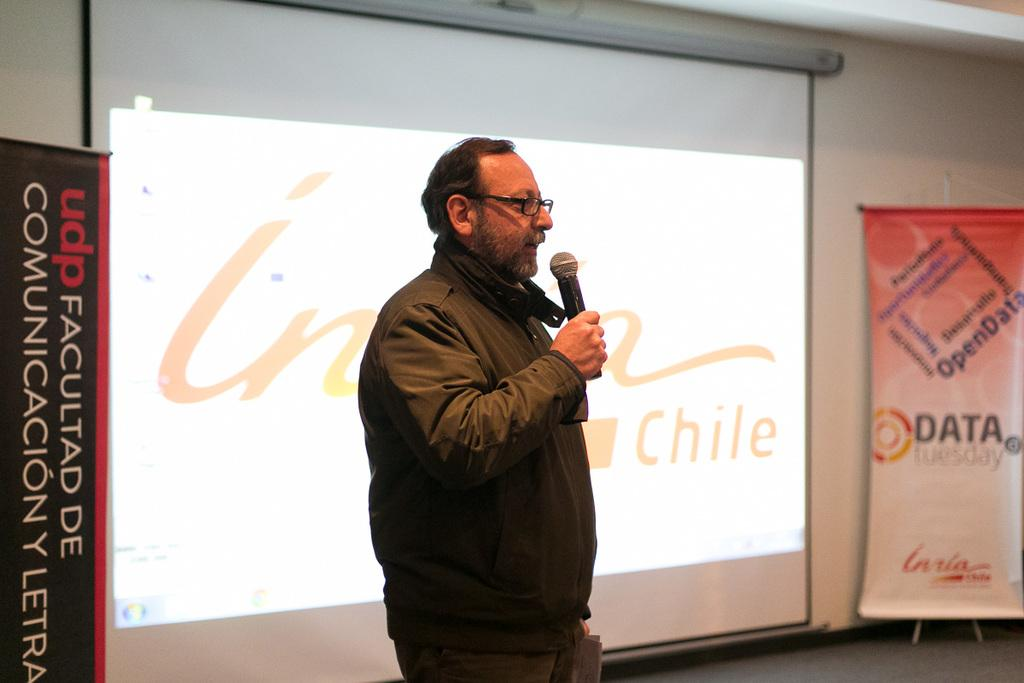<image>
Write a terse but informative summary of the picture. A man is presenting with a microphone about OpenData in Chile. 